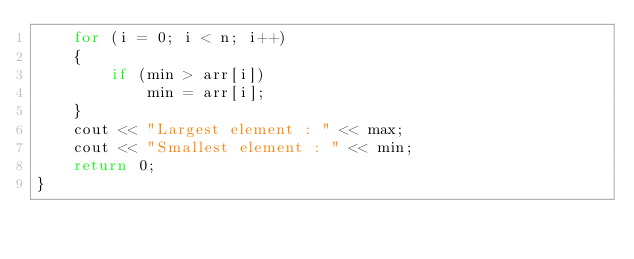Convert code to text. <code><loc_0><loc_0><loc_500><loc_500><_C++_>    for (i = 0; i < n; i++)
    {
        if (min > arr[i])
            min = arr[i];
    }
    cout << "Largest element : " << max;
    cout << "Smallest element : " << min;
    return 0;
}</code> 